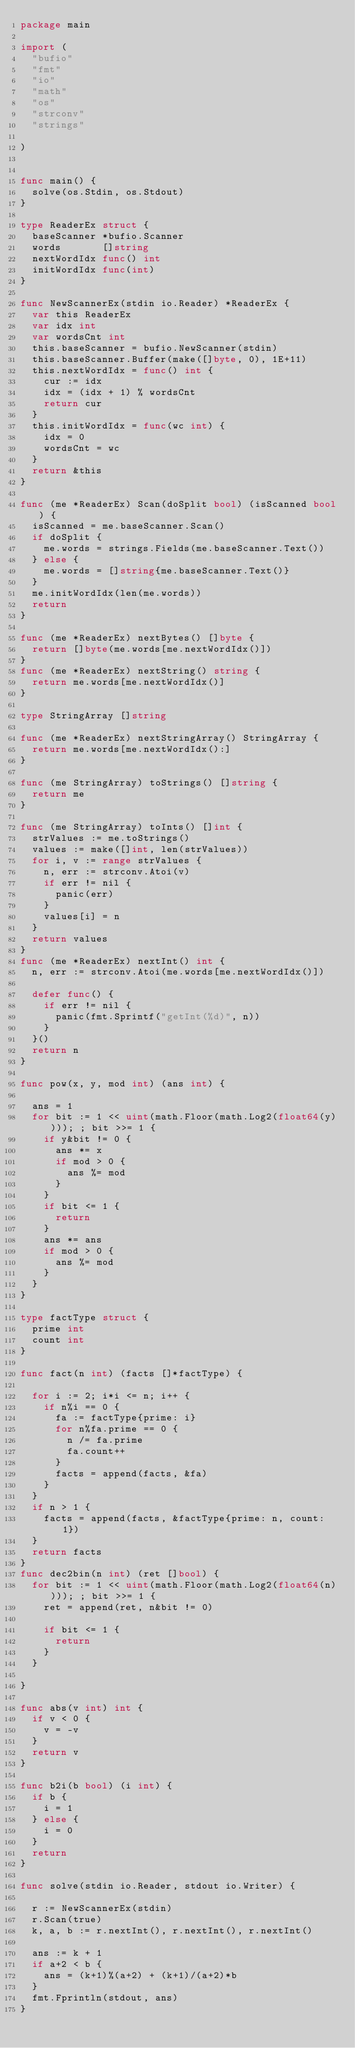Convert code to text. <code><loc_0><loc_0><loc_500><loc_500><_Go_>package main

import (
	"bufio"
	"fmt"
	"io"
	"math"
	"os"
	"strconv"
	"strings"

)


func main() {
	solve(os.Stdin, os.Stdout)
}

type ReaderEx struct {
	baseScanner *bufio.Scanner
	words       []string
	nextWordIdx func() int
	initWordIdx func(int)
}

func NewScannerEx(stdin io.Reader) *ReaderEx {
	var this ReaderEx
	var idx int
	var wordsCnt int
	this.baseScanner = bufio.NewScanner(stdin)
	this.baseScanner.Buffer(make([]byte, 0), 1E+11)
	this.nextWordIdx = func() int {
		cur := idx
		idx = (idx + 1) % wordsCnt
		return cur
	}
	this.initWordIdx = func(wc int) {
		idx = 0
		wordsCnt = wc
	}
	return &this
}

func (me *ReaderEx) Scan(doSplit bool) (isScanned bool) {
	isScanned = me.baseScanner.Scan()
	if doSplit {
		me.words = strings.Fields(me.baseScanner.Text())
	} else {
		me.words = []string{me.baseScanner.Text()}
	}
	me.initWordIdx(len(me.words))
	return
}

func (me *ReaderEx) nextBytes() []byte {
	return []byte(me.words[me.nextWordIdx()])
}
func (me *ReaderEx) nextString() string {
	return me.words[me.nextWordIdx()]
}

type StringArray []string

func (me *ReaderEx) nextStringArray() StringArray {
	return me.words[me.nextWordIdx():]
}

func (me StringArray) toStrings() []string {
	return me
}

func (me StringArray) toInts() []int {
	strValues := me.toStrings()
	values := make([]int, len(strValues))
	for i, v := range strValues {
		n, err := strconv.Atoi(v)
		if err != nil {
			panic(err)
		}
		values[i] = n
	}
	return values
}
func (me *ReaderEx) nextInt() int {
	n, err := strconv.Atoi(me.words[me.nextWordIdx()])

	defer func() {
		if err != nil {
			panic(fmt.Sprintf("getInt(%d)", n))
		}
	}()
	return n
}

func pow(x, y, mod int) (ans int) {

	ans = 1
	for bit := 1 << uint(math.Floor(math.Log2(float64(y)))); ; bit >>= 1 {
		if y&bit != 0 {
			ans *= x
			if mod > 0 {
				ans %= mod
			}
		}
		if bit <= 1 {
			return
		}
		ans *= ans
		if mod > 0 {
			ans %= mod
		}
	}
}

type factType struct {
	prime int
	count int
}

func fact(n int) (facts []*factType) {

	for i := 2; i*i <= n; i++ {
		if n%i == 0 {
			fa := factType{prime: i}
			for n%fa.prime == 0 {
				n /= fa.prime
				fa.count++
			}
			facts = append(facts, &fa)
		}
	}
	if n > 1 {
		facts = append(facts, &factType{prime: n, count: 1})
	}
	return facts
}
func dec2bin(n int) (ret []bool) {
	for bit := 1 << uint(math.Floor(math.Log2(float64(n)))); ; bit >>= 1 {
		ret = append(ret, n&bit != 0)

		if bit <= 1 {
			return
		}
	}

}

func abs(v int) int {
	if v < 0 {
		v = -v
	}
	return v
}

func b2i(b bool) (i int) {
	if b {
		i = 1
	} else {
		i = 0
	}
	return
}

func solve(stdin io.Reader, stdout io.Writer) {

	r := NewScannerEx(stdin)
	r.Scan(true)
	k, a, b := r.nextInt(), r.nextInt(), r.nextInt()

	ans := k + 1
	if a+2 < b {
		ans = (k+1)%(a+2) + (k+1)/(a+2)*b
	}
	fmt.Fprintln(stdout, ans)
}
</code> 